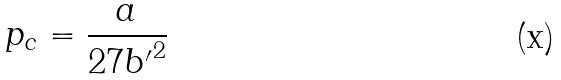Convert formula to latex. <formula><loc_0><loc_0><loc_500><loc_500>p _ { c } = \frac { a } { 2 7 { b ^ { \prime } } ^ { 2 } }</formula> 